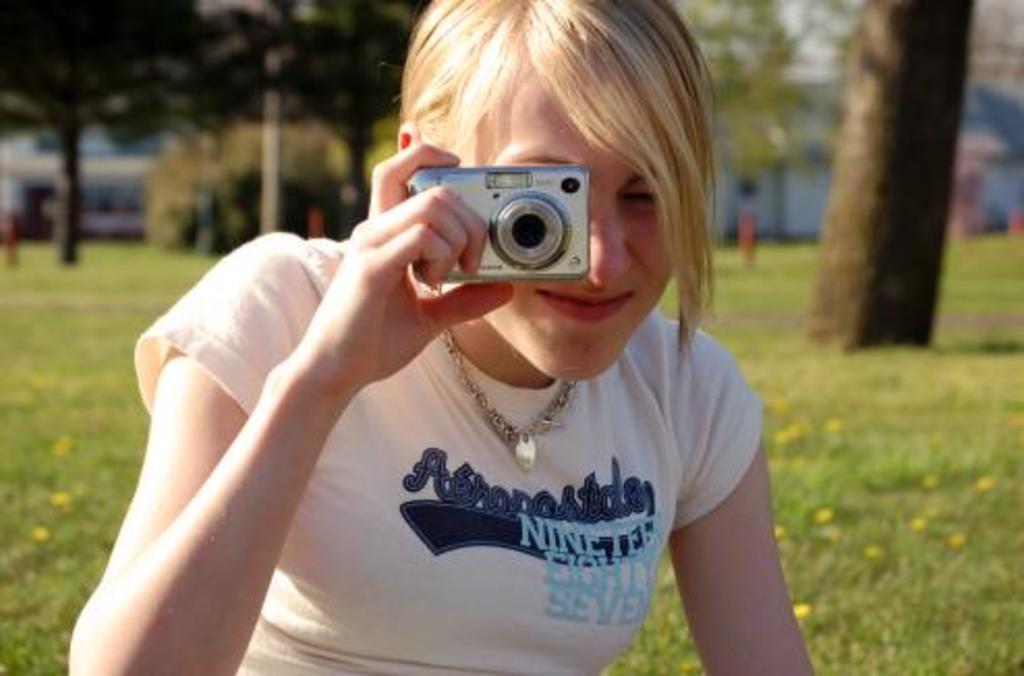In one or two sentences, can you explain what this image depicts? This picture is of the outside. In the center there is a Woman holding a Camera and taking pictures. In the background we can see the Trees and also the green grass. 